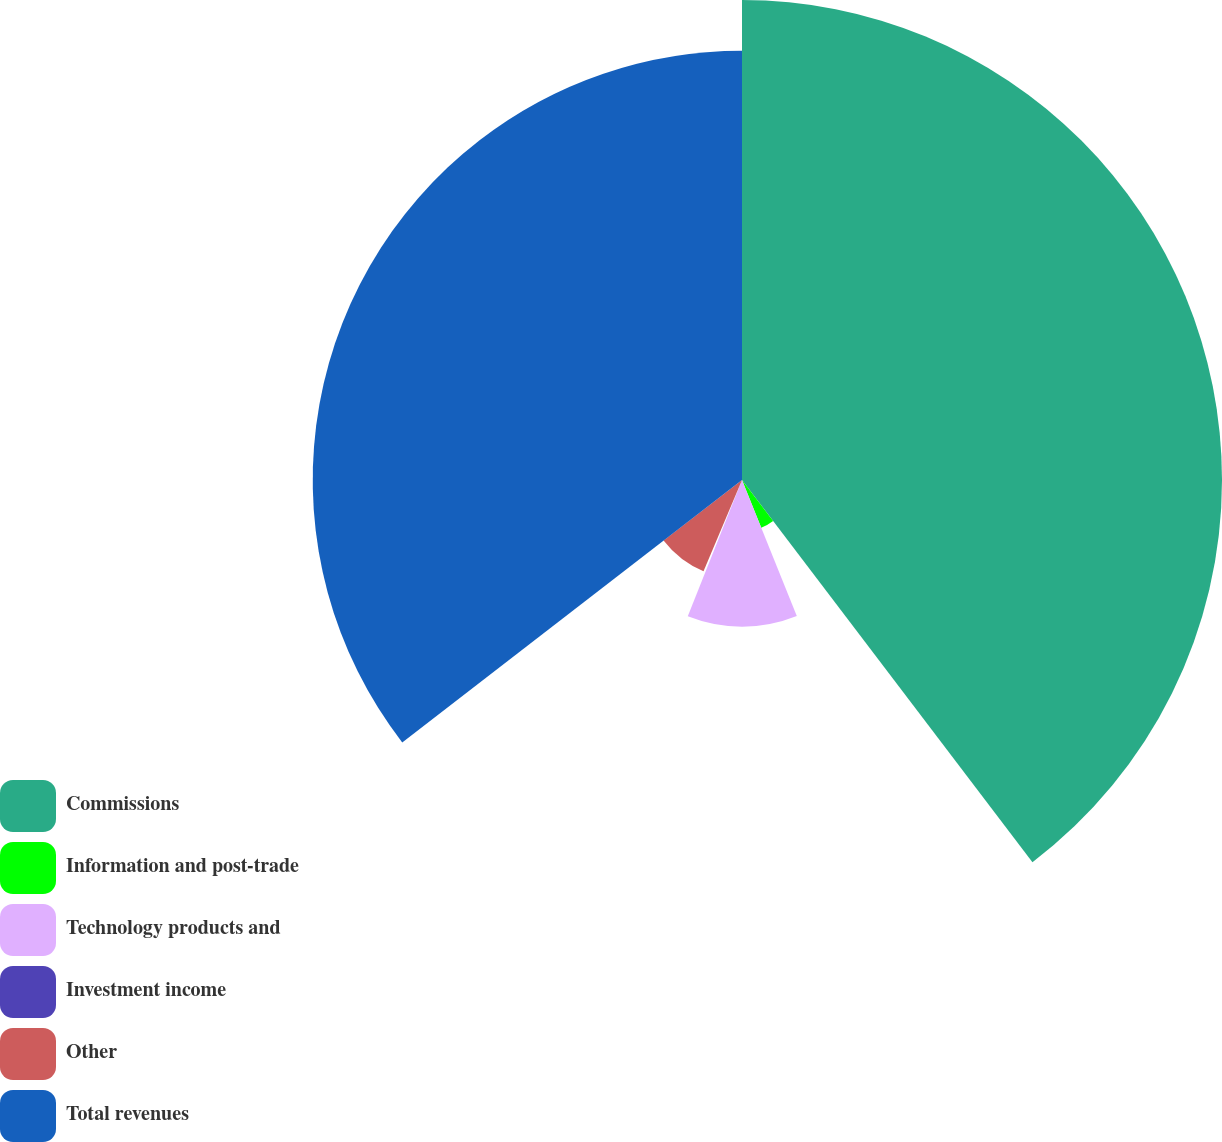<chart> <loc_0><loc_0><loc_500><loc_500><pie_chart><fcel>Commissions<fcel>Information and post-trade<fcel>Technology products and<fcel>Investment income<fcel>Other<fcel>Total revenues<nl><fcel>39.66%<fcel>4.25%<fcel>12.12%<fcel>0.32%<fcel>8.19%<fcel>35.47%<nl></chart> 